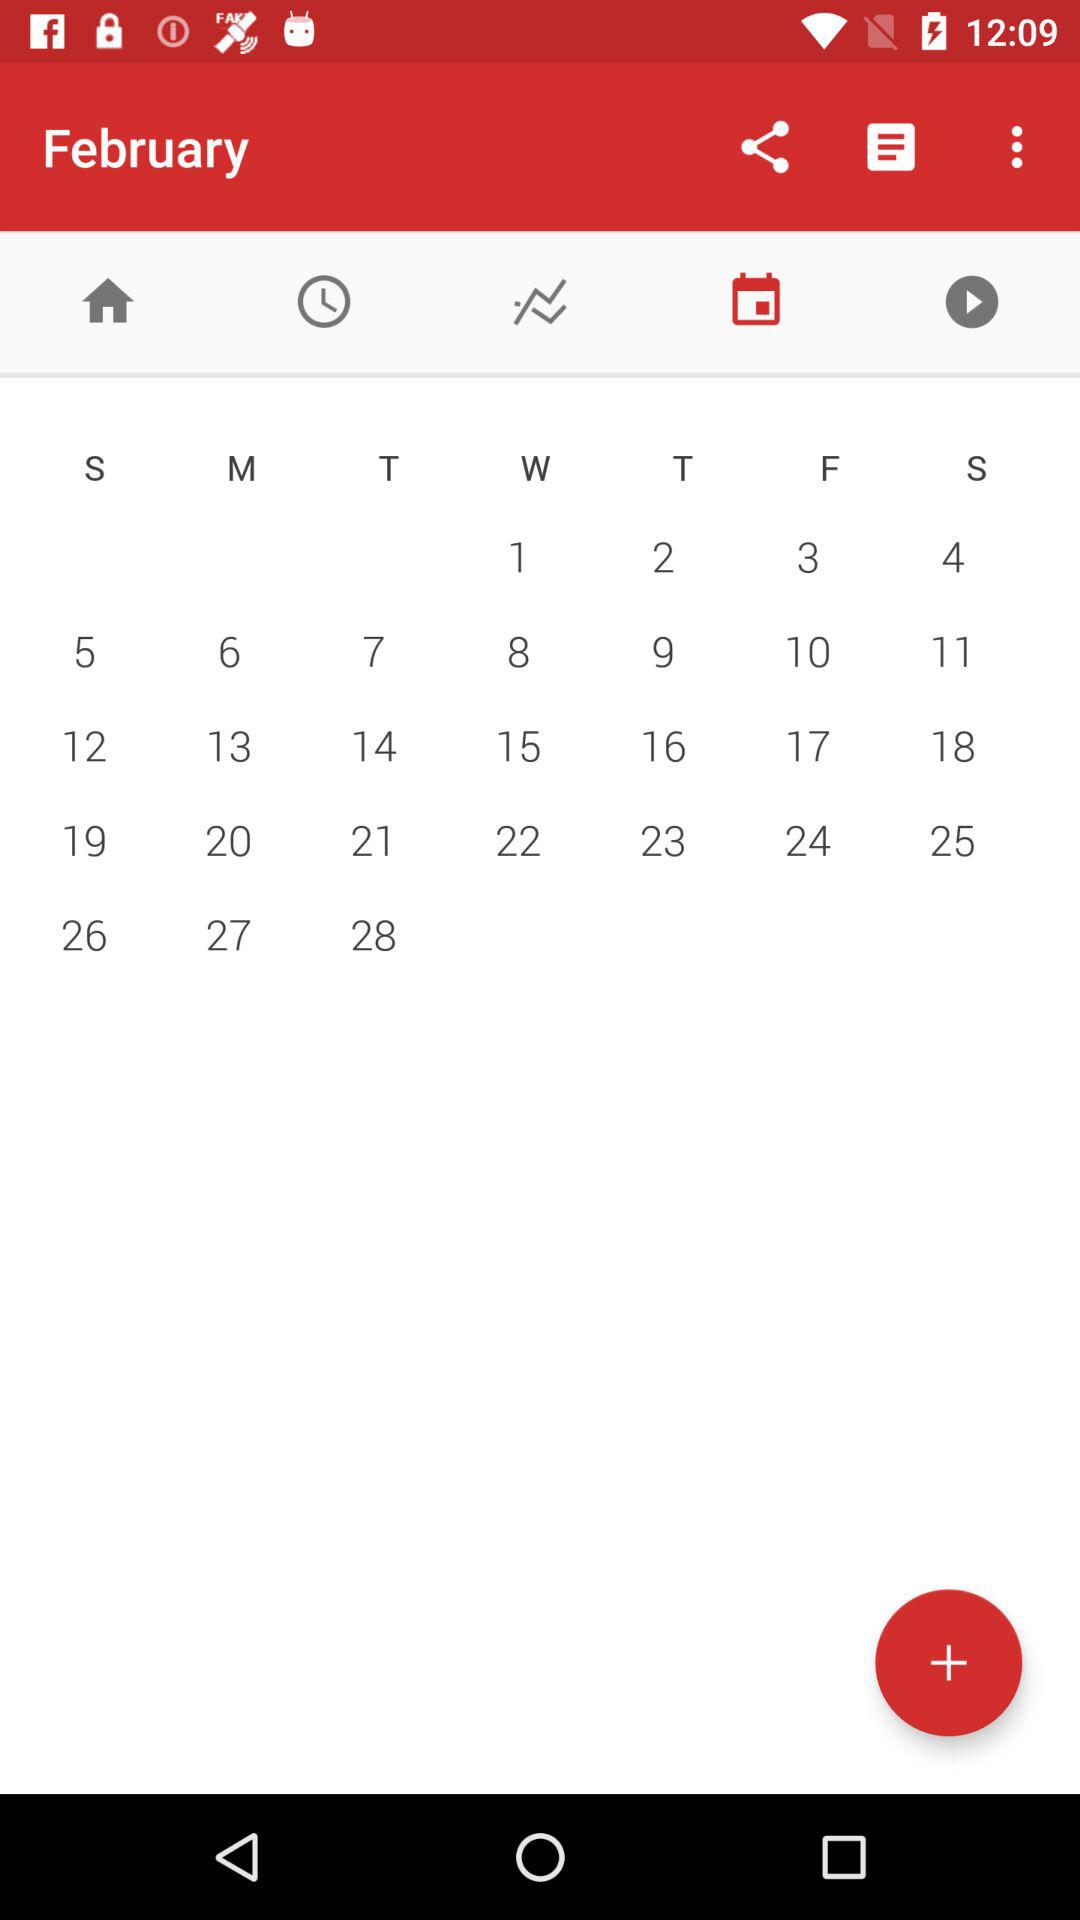What is the day of February 1? The day is "Wednesday". 